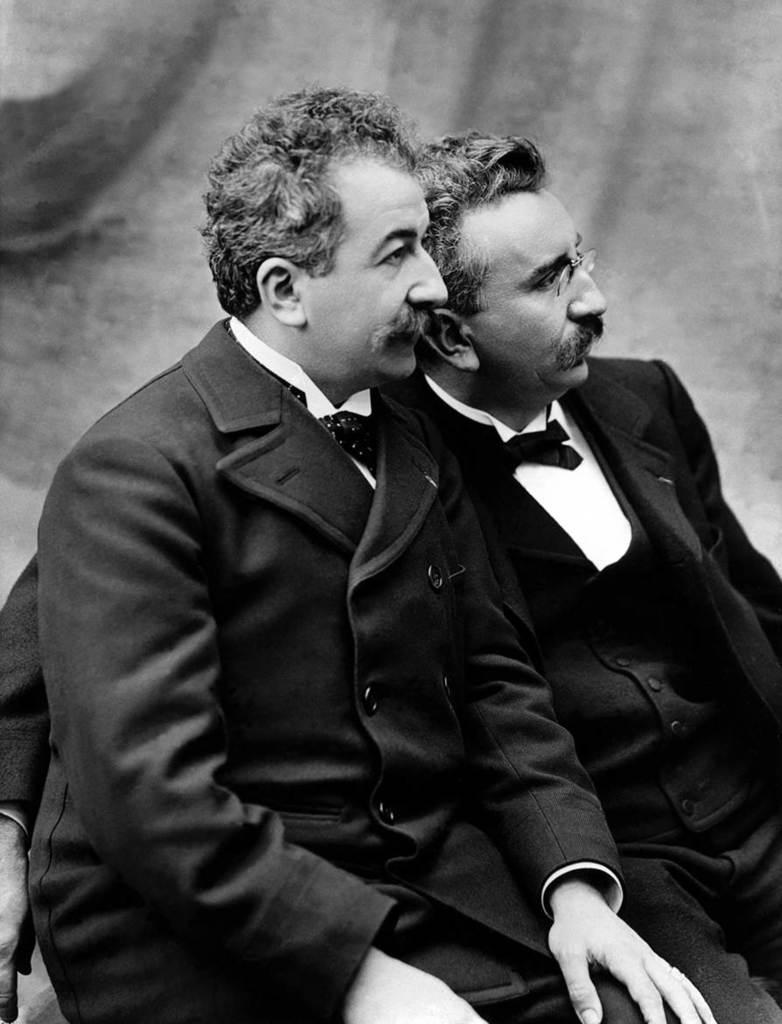Could you give a brief overview of what you see in this image? In this black and white image there are two men sitting. Behind them there is a wall. 